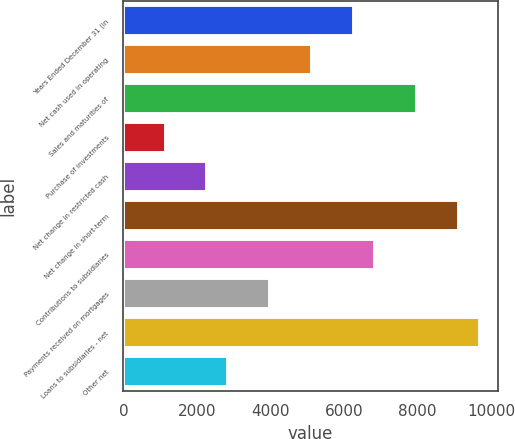<chart> <loc_0><loc_0><loc_500><loc_500><bar_chart><fcel>Years Ended December 31 (in<fcel>Net cash used in operating<fcel>Sales and maturities of<fcel>Purchase of investments<fcel>Net change in restricted cash<fcel>Net change in short-term<fcel>Contributions to subsidiaries<fcel>Payments received on mortgages<fcel>Loans to subsidiaries - net<fcel>Other net<nl><fcel>6272.5<fcel>5133.5<fcel>7981<fcel>1147<fcel>2286<fcel>9120<fcel>6842<fcel>3994.5<fcel>9689.5<fcel>2855.5<nl></chart> 